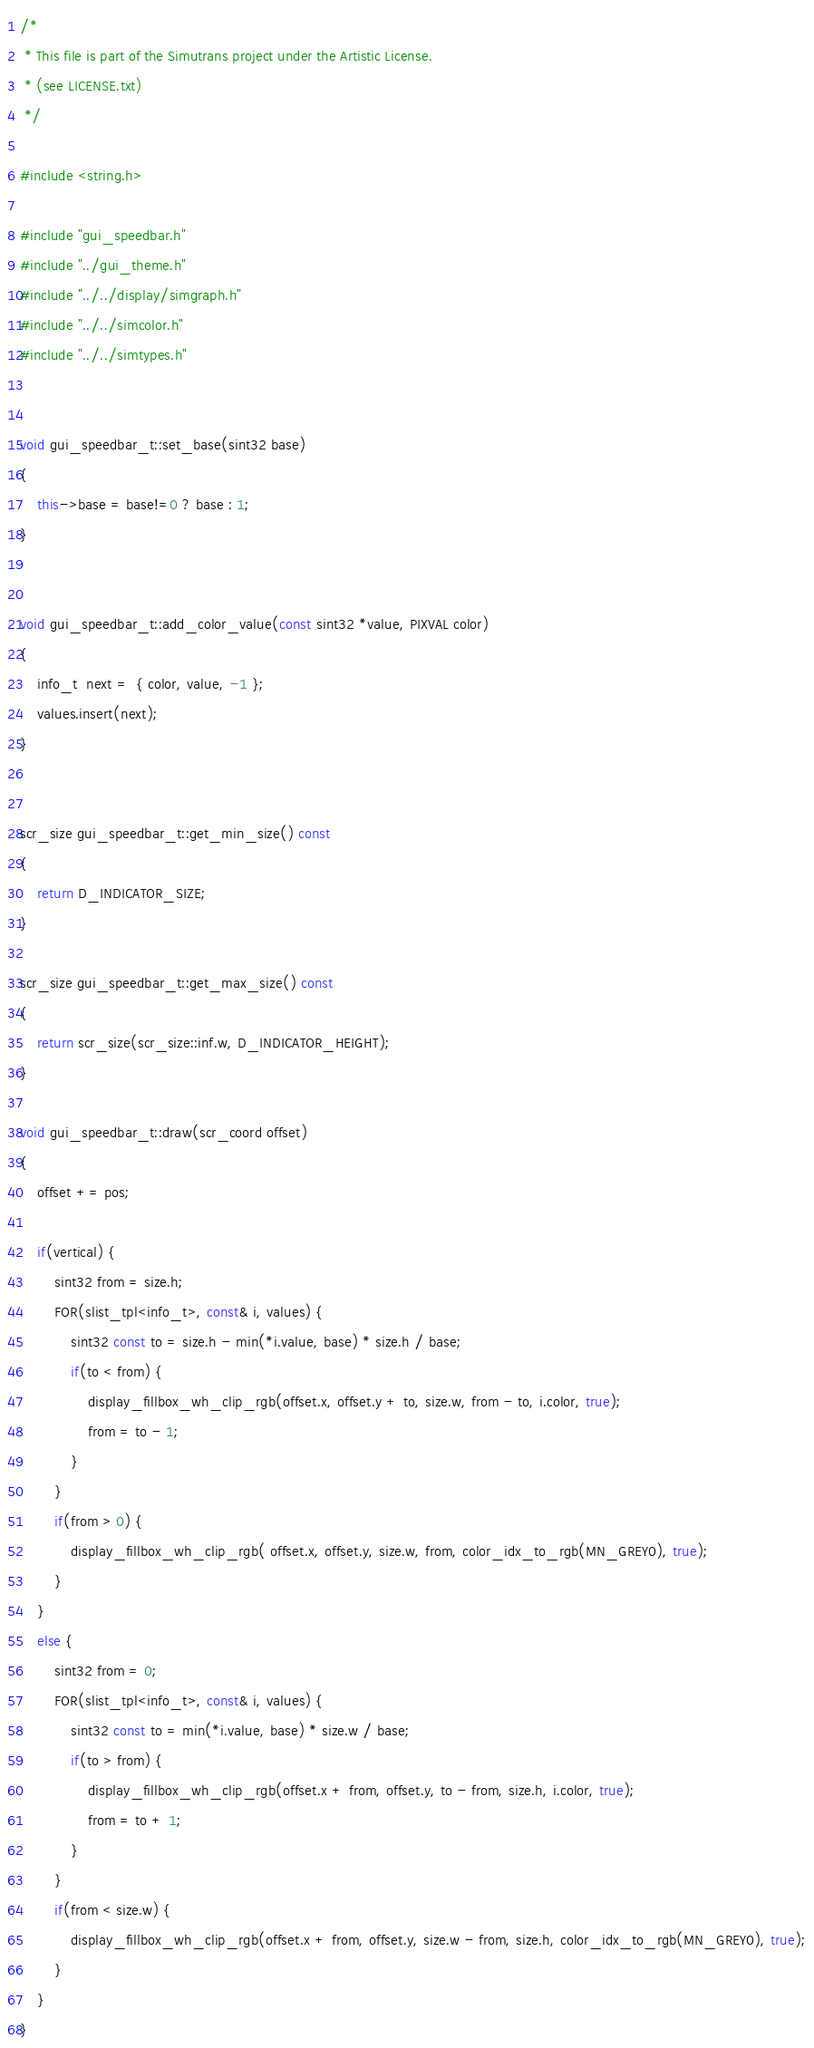Convert code to text. <code><loc_0><loc_0><loc_500><loc_500><_C++_>/*
 * This file is part of the Simutrans project under the Artistic License.
 * (see LICENSE.txt)
 */

#include <string.h>

#include "gui_speedbar.h"
#include "../gui_theme.h"
#include "../../display/simgraph.h"
#include "../../simcolor.h"
#include "../../simtypes.h"


void gui_speedbar_t::set_base(sint32 base)
{
	this->base = base!=0 ? base : 1;
}


void gui_speedbar_t::add_color_value(const sint32 *value, PIXVAL color)
{
	info_t  next =  { color, value, -1 };
	values.insert(next);
}


scr_size gui_speedbar_t::get_min_size() const
{
	return D_INDICATOR_SIZE;
}

scr_size gui_speedbar_t::get_max_size() const
{
	return scr_size(scr_size::inf.w, D_INDICATOR_HEIGHT);
}

void gui_speedbar_t::draw(scr_coord offset)
{
	offset += pos;

	if(vertical) {
		sint32 from = size.h;
		FOR(slist_tpl<info_t>, const& i, values) {
			sint32 const to = size.h - min(*i.value, base) * size.h / base;
			if(to < from) {
				display_fillbox_wh_clip_rgb(offset.x, offset.y + to, size.w, from - to, i.color, true);
				from = to - 1;
			}
		}
		if(from > 0) {
			display_fillbox_wh_clip_rgb( offset.x, offset.y, size.w, from, color_idx_to_rgb(MN_GREY0), true);
		}
	}
	else {
		sint32 from = 0;
		FOR(slist_tpl<info_t>, const& i, values) {
			sint32 const to = min(*i.value, base) * size.w / base;
			if(to > from) {
				display_fillbox_wh_clip_rgb(offset.x + from, offset.y, to - from, size.h, i.color, true);
				from = to + 1;
			}
		}
		if(from < size.w) {
			display_fillbox_wh_clip_rgb(offset.x + from, offset.y, size.w - from, size.h, color_idx_to_rgb(MN_GREY0), true);
		}
	}
}
</code> 